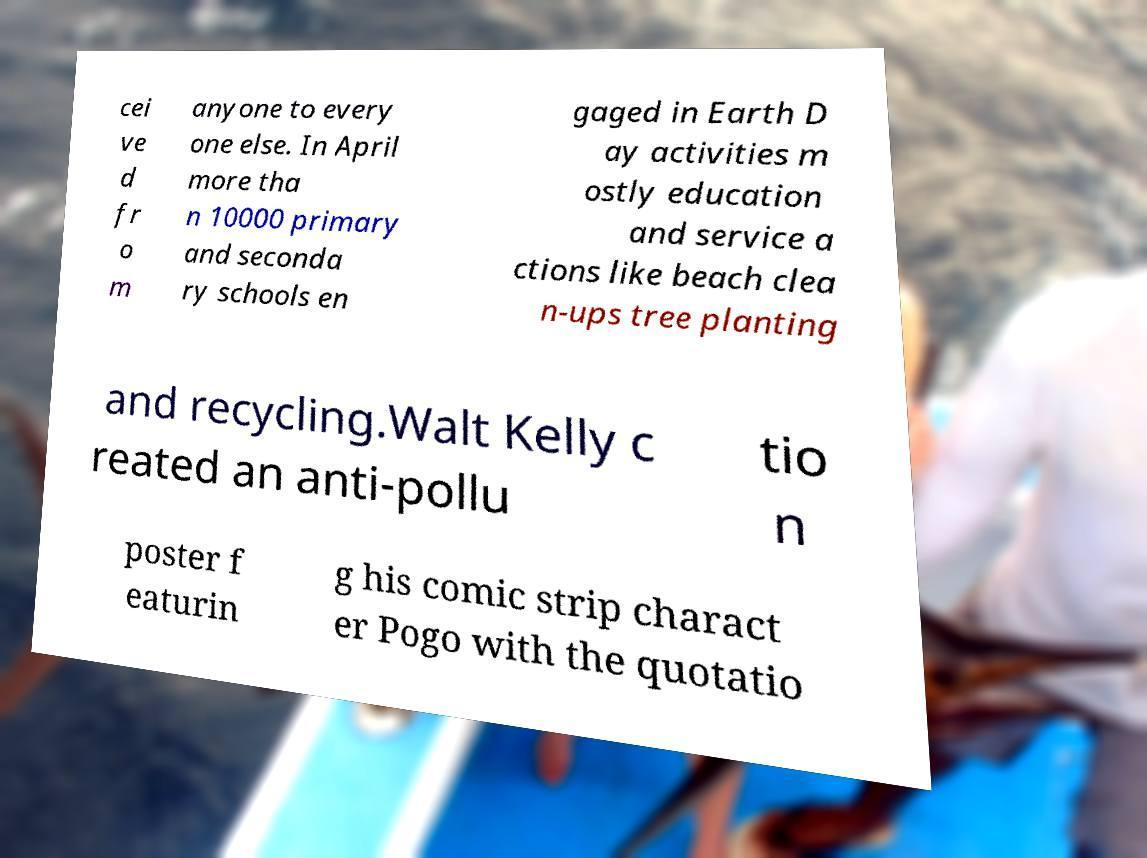Could you extract and type out the text from this image? cei ve d fr o m anyone to every one else. In April more tha n 10000 primary and seconda ry schools en gaged in Earth D ay activities m ostly education and service a ctions like beach clea n-ups tree planting and recycling.Walt Kelly c reated an anti-pollu tio n poster f eaturin g his comic strip charact er Pogo with the quotatio 